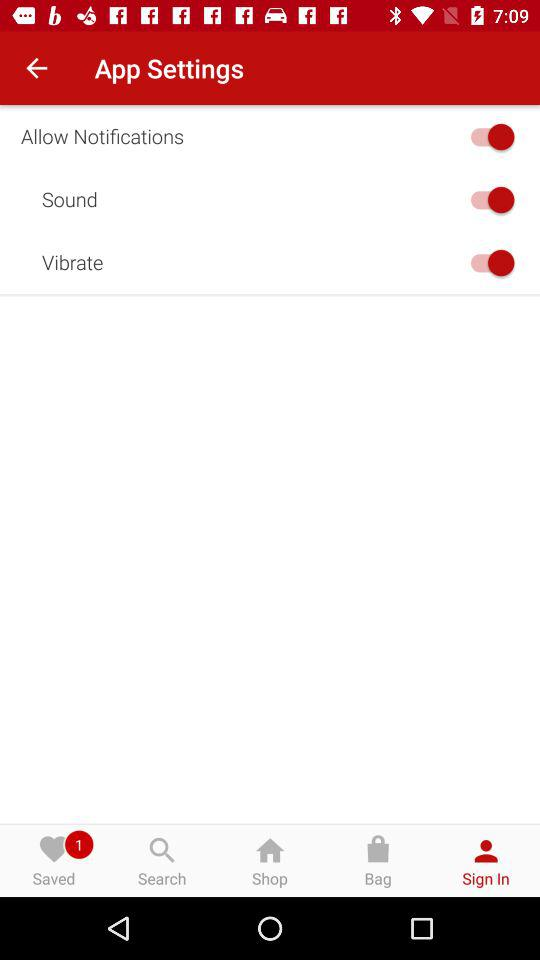Which tab am I using? You are using the tab "Sign In". 